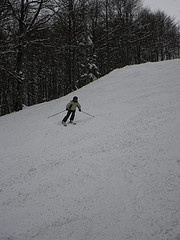Describe the objects in this image and their specific colors. I can see people in black, gray, and darkgray tones and skis in black and gray tones in this image. 